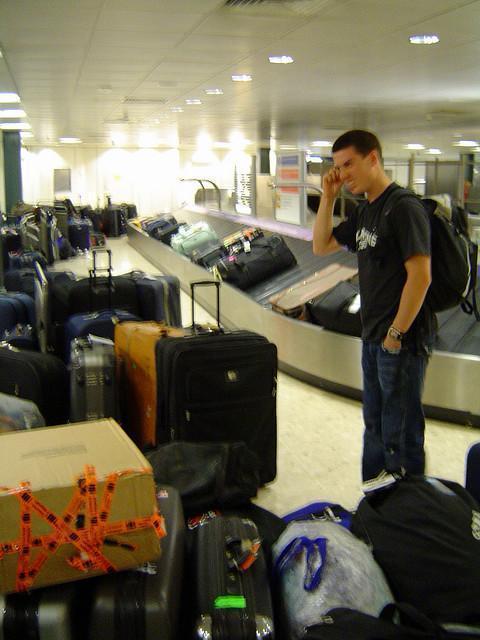What kind of reaction the person shows?
From the following set of four choices, select the accurate answer to respond to the question.
Options: Smiling, laughing, ordering, confusion. Confusion. 